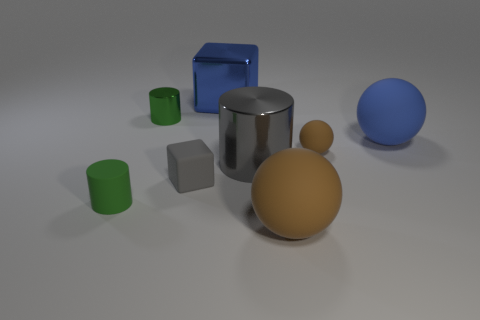Add 1 brown matte objects. How many objects exist? 9 Subtract all cubes. How many objects are left? 6 Add 1 large metal objects. How many large metal objects exist? 3 Subtract 0 yellow blocks. How many objects are left? 8 Subtract all tiny rubber objects. Subtract all gray cylinders. How many objects are left? 4 Add 2 green shiny cylinders. How many green shiny cylinders are left? 3 